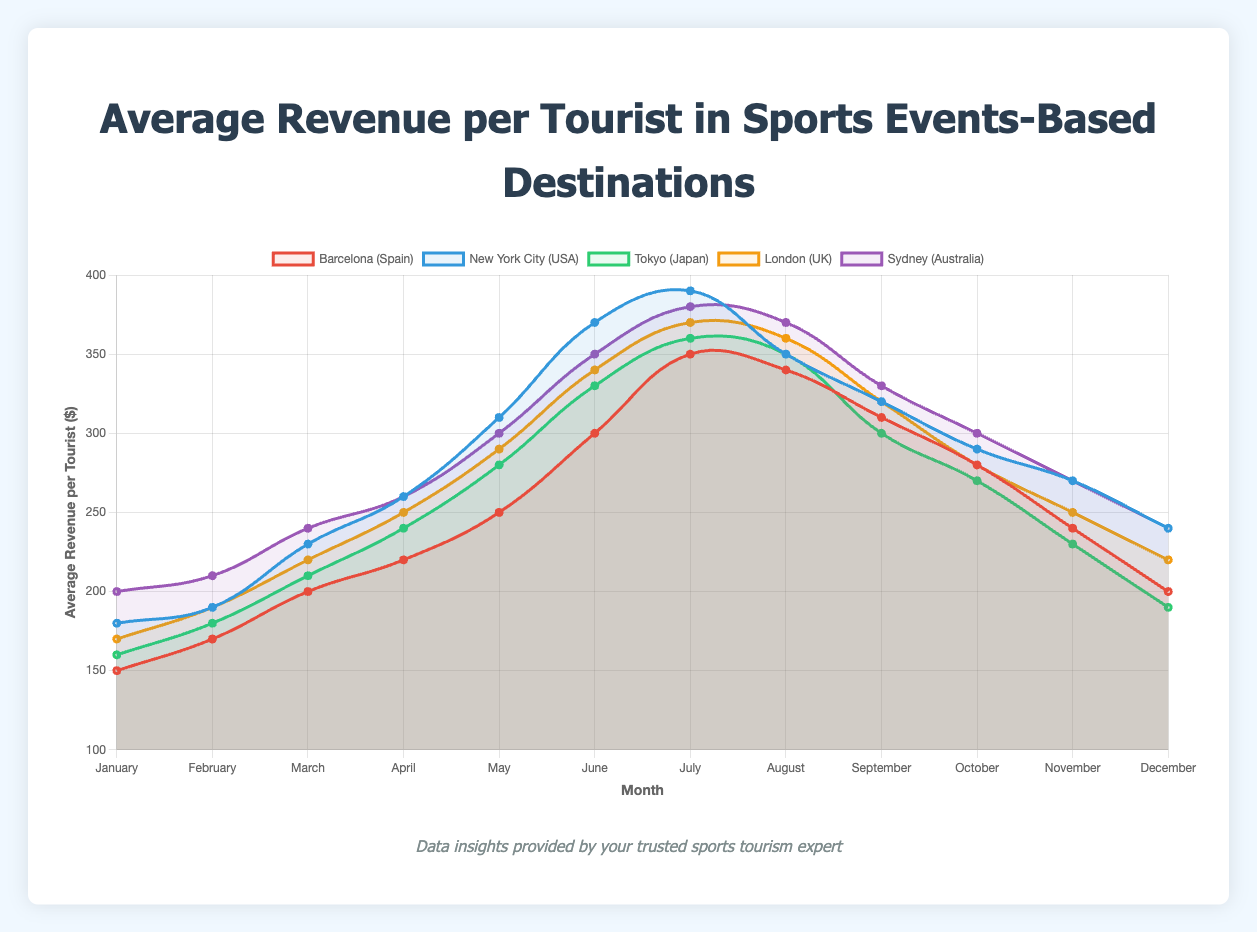Which destination has the highest average revenue in July? In the chart, the y-axis represents the average revenue per tourist, and the x-axis represents the months. In July, the line for "New York City (USA)" peaks the highest among all destinations.
Answer: New York City (USA) How does the revenue trend in Tokyo compare between the months of May and September? The y-axis shows the revenue values. For Tokyo, in May the revenue is 280, and in September it is 300. Comparing these values, the revenue in September is higher than in May.
Answer: September is higher What is the average revenue per tourist in Sydney during the second quarter (April to June)? The second quarter includes April, May, and June. The revenues for Sydney during these months are 260, 300, and 350, respectively. Summing these gives 910, and averaging this over 3 months results in 910/3 = 303.33.
Answer: 303.33 Which destination has the lowest revenue in December, and what is that revenue? By examining the December data in the chart, the lowest revenue line is for Tokyo, which ends at 190.
Answer: Tokyo (190) Is there a month where New York City’s revenue is equal to or less than any other destination? If yes, which month(s) and destination(s)? By examining all months, New York City's lowest revenue (180 in January) is compared to other destinations. In January, Barcelona (150) and Tokyo (160) have lower revenues than New York City.
Answer: No Which destination shows the most fluctuation throughout the year? To determine fluctuation, examine the range (difference between highest and lowest points) for each destination. New York City shows the highest fluctuation from 180 (January) to 390 (July), a range of 210.
Answer: New York City During which month is the revenue for London at its peak? Looking at the chart, the highest point for London is in July, where the line reaches 370.
Answer: July How does the June revenue in Barcelona compare to Sydney? In the chart for June, Barcelona's revenue is 300, while Sydney's revenue is 350. Thus, Sydney's revenue is 50 more than Barcelona's.
Answer: Sydney is higher What is the cumulative revenue for Barcelona in the third quarter (July to September)? The third quarter includes July, August, and September. The revenues for Barcelona during these months are 350, 340, and 310, respectively. Summing these gives 1000.
Answer: 1000 Which destination shows a consistent increase in revenue from January to July? Reviewing each destination's data, New York City shows a consistent revenue increase each month from January (180) to July (390).
Answer: New York City 